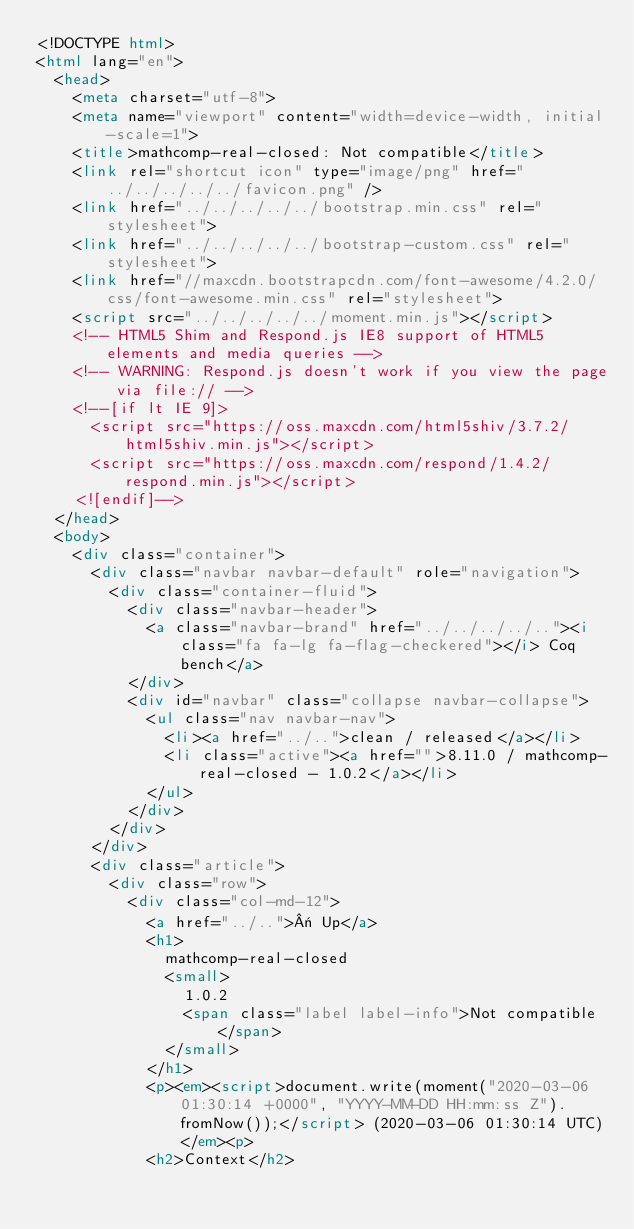<code> <loc_0><loc_0><loc_500><loc_500><_HTML_><!DOCTYPE html>
<html lang="en">
  <head>
    <meta charset="utf-8">
    <meta name="viewport" content="width=device-width, initial-scale=1">
    <title>mathcomp-real-closed: Not compatible</title>
    <link rel="shortcut icon" type="image/png" href="../../../../../favicon.png" />
    <link href="../../../../../bootstrap.min.css" rel="stylesheet">
    <link href="../../../../../bootstrap-custom.css" rel="stylesheet">
    <link href="//maxcdn.bootstrapcdn.com/font-awesome/4.2.0/css/font-awesome.min.css" rel="stylesheet">
    <script src="../../../../../moment.min.js"></script>
    <!-- HTML5 Shim and Respond.js IE8 support of HTML5 elements and media queries -->
    <!-- WARNING: Respond.js doesn't work if you view the page via file:// -->
    <!--[if lt IE 9]>
      <script src="https://oss.maxcdn.com/html5shiv/3.7.2/html5shiv.min.js"></script>
      <script src="https://oss.maxcdn.com/respond/1.4.2/respond.min.js"></script>
    <![endif]-->
  </head>
  <body>
    <div class="container">
      <div class="navbar navbar-default" role="navigation">
        <div class="container-fluid">
          <div class="navbar-header">
            <a class="navbar-brand" href="../../../../.."><i class="fa fa-lg fa-flag-checkered"></i> Coq bench</a>
          </div>
          <div id="navbar" class="collapse navbar-collapse">
            <ul class="nav navbar-nav">
              <li><a href="../..">clean / released</a></li>
              <li class="active"><a href="">8.11.0 / mathcomp-real-closed - 1.0.2</a></li>
            </ul>
          </div>
        </div>
      </div>
      <div class="article">
        <div class="row">
          <div class="col-md-12">
            <a href="../..">« Up</a>
            <h1>
              mathcomp-real-closed
              <small>
                1.0.2
                <span class="label label-info">Not compatible</span>
              </small>
            </h1>
            <p><em><script>document.write(moment("2020-03-06 01:30:14 +0000", "YYYY-MM-DD HH:mm:ss Z").fromNow());</script> (2020-03-06 01:30:14 UTC)</em><p>
            <h2>Context</h2></code> 